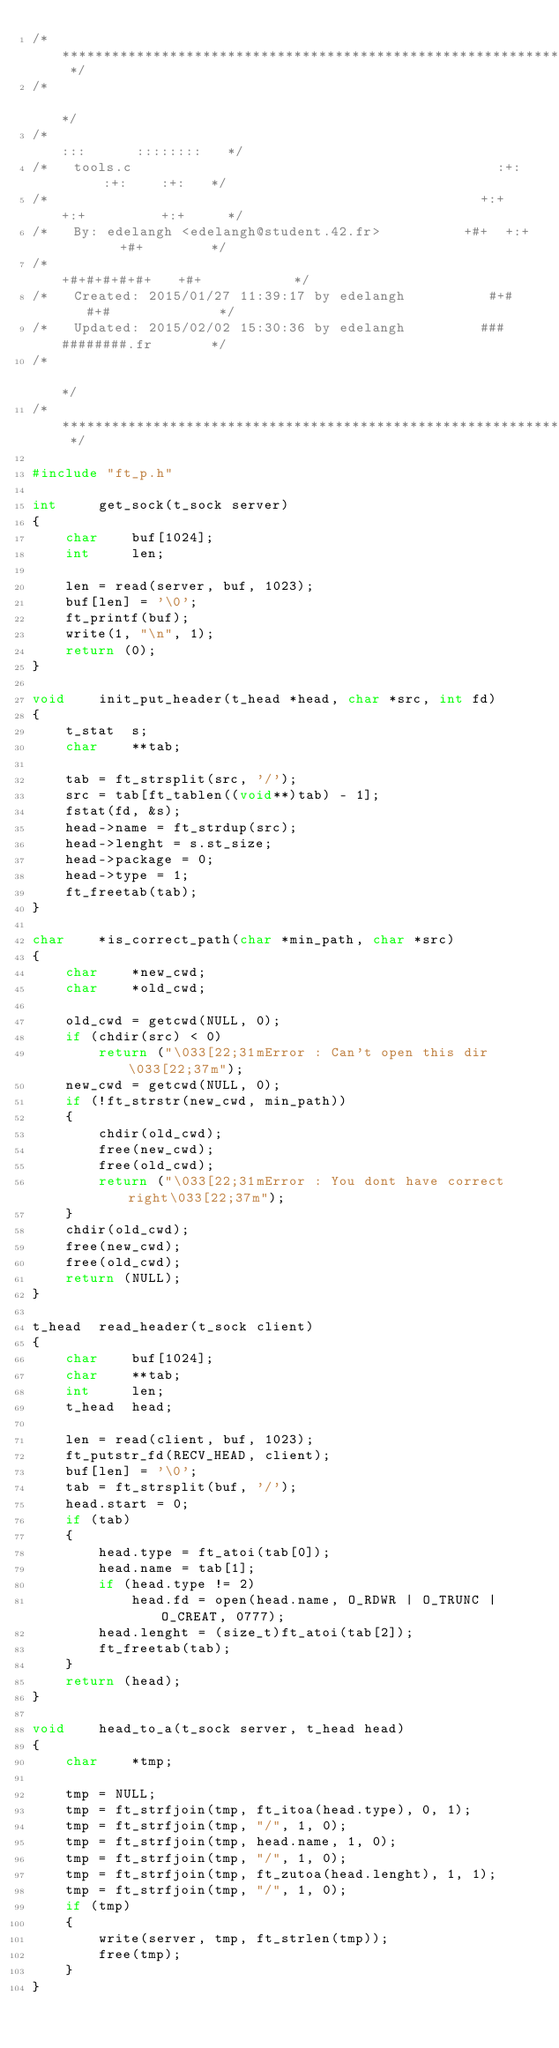<code> <loc_0><loc_0><loc_500><loc_500><_C_>/* ************************************************************************** */
/*                                                                            */
/*                                                        :::      ::::::::   */
/*   tools.c                                            :+:      :+:    :+:   */
/*                                                    +:+ +:+         +:+     */
/*   By: edelangh <edelangh@student.42.fr>          +#+  +:+       +#+        */
/*                                                +#+#+#+#+#+   +#+           */
/*   Created: 2015/01/27 11:39:17 by edelangh          #+#    #+#             */
/*   Updated: 2015/02/02 15:30:36 by edelangh         ###   ########.fr       */
/*                                                                            */
/* ************************************************************************** */

#include "ft_p.h"

int		get_sock(t_sock server)
{
	char	buf[1024];
	int		len;

	len = read(server, buf, 1023);
	buf[len] = '\0';
	ft_printf(buf);
	write(1, "\n", 1);
	return (0);
}

void	init_put_header(t_head *head, char *src, int fd)
{
	t_stat	s;
	char	**tab;

	tab = ft_strsplit(src, '/');
	src = tab[ft_tablen((void**)tab) - 1];
	fstat(fd, &s);
	head->name = ft_strdup(src);
	head->lenght = s.st_size;
	head->package = 0;
	head->type = 1;
	ft_freetab(tab);
}

char	*is_correct_path(char *min_path, char *src)
{
	char	*new_cwd;
	char	*old_cwd;

	old_cwd = getcwd(NULL, 0);
	if (chdir(src) < 0)
		return ("\033[22;31mError : Can't open this dir\033[22;37m");
	new_cwd = getcwd(NULL, 0);
	if (!ft_strstr(new_cwd, min_path))
	{
		chdir(old_cwd);
		free(new_cwd);
		free(old_cwd);
		return ("\033[22;31mError : You dont have correct right\033[22;37m");
	}
	chdir(old_cwd);
	free(new_cwd);
	free(old_cwd);
	return (NULL);
}

t_head	read_header(t_sock client)
{
	char	buf[1024];
	char	**tab;
	int		len;
	t_head	head;

	len = read(client, buf, 1023);
	ft_putstr_fd(RECV_HEAD, client);
	buf[len] = '\0';
	tab = ft_strsplit(buf, '/');
	head.start = 0;
	if (tab)
	{
		head.type = ft_atoi(tab[0]);
		head.name = tab[1];
		if (head.type != 2)
			head.fd = open(head.name, O_RDWR | O_TRUNC | O_CREAT, 0777);
		head.lenght = (size_t)ft_atoi(tab[2]);
		ft_freetab(tab);
	}
	return (head);
}

void	head_to_a(t_sock server, t_head head)
{
	char	*tmp;

	tmp = NULL;
	tmp = ft_strfjoin(tmp, ft_itoa(head.type), 0, 1);
	tmp = ft_strfjoin(tmp, "/", 1, 0);
	tmp = ft_strfjoin(tmp, head.name, 1, 0);
	tmp = ft_strfjoin(tmp, "/", 1, 0);
	tmp = ft_strfjoin(tmp, ft_zutoa(head.lenght), 1, 1);
	tmp = ft_strfjoin(tmp, "/", 1, 0);
	if (tmp)
	{
		write(server, tmp, ft_strlen(tmp));
		free(tmp);
	}
}
</code> 